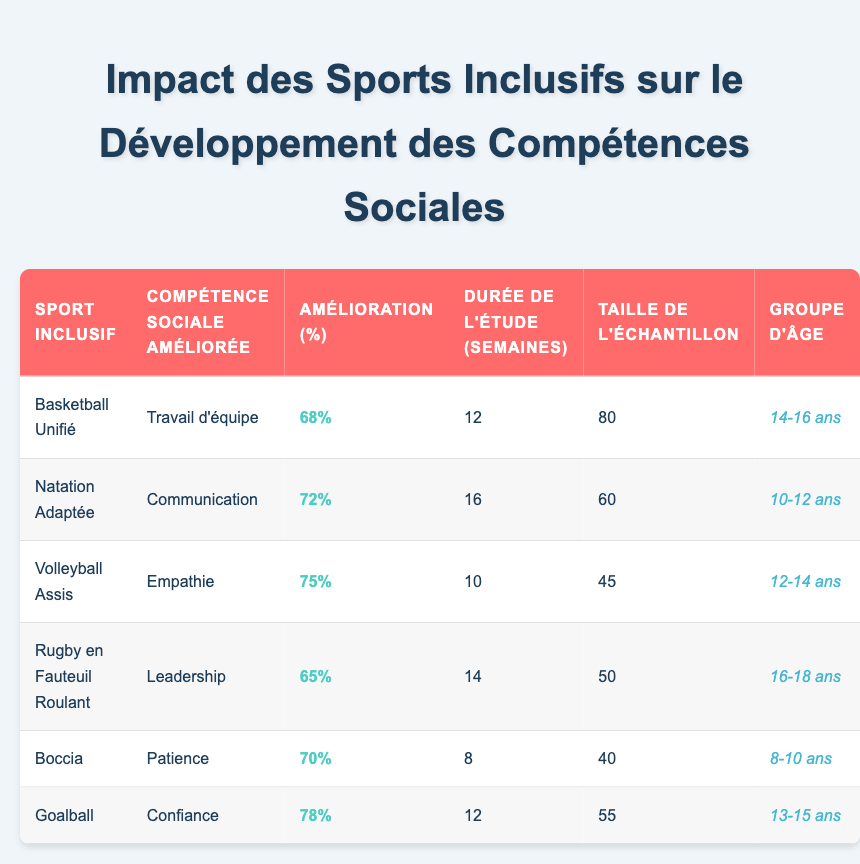What is the sport that showed the highest percentage improvement in social skills? By inspecting the table, I look at the "Percentage Improvement" column for each sport. The highest value is 78%, associated with the sport "Goal Ball."
Answer: Goal Ball How many weeks did the study on Adapted Swimming last? The study duration for Adapted Swimming is directly listed in the table under "Study Duration (Weeks)," which shows 16 weeks.
Answer: 16 weeks Which social skill was improved by Boccia and what was the percentage? The table shows that Boccia improved the social skill "Patience" with a percentage improvement of 70%.
Answer: Patience, 70% What is the average percentage improvement of the social skills for all sports listed? To calculate the average, I add all the percentage improvements: (68 + 72 + 75 + 65 + 70 + 78) = 428. Then I divide by the number of sports, which is 6, giving an average of 428/6 ≈ 71.33.
Answer: 71.33% Is it true that Wheelchair Rugby had the shortest study duration? Comparing the "Study Duration (Weeks)" for Wheelchair Rugby (14 weeks) with other sports, I can see that Boccia had the shortest at 8 weeks. Therefore, the statement is false.
Answer: No Which age group had the highest sample size? By reading the "Sample Size" column, I find that Unified Basketball had the highest sample size of 80, which corresponds to the age group 14-16 years.
Answer: 14-16 years What is the difference in percentage improvement between Sitting Volleyball and Goal Ball? Sitting Volleyball shows a percentage improvement of 75%, while Goal Ball shows 78%. The difference is calculated as 78 - 75 = 3.
Answer: 3% Which sport helped improve Leadership, and how long was the study conducted? The table indicates that Wheelchair Rugby improved the social skill "Leadership," and the duration of the study was 14 weeks.
Answer: Wheelchair Rugby, 14 weeks 